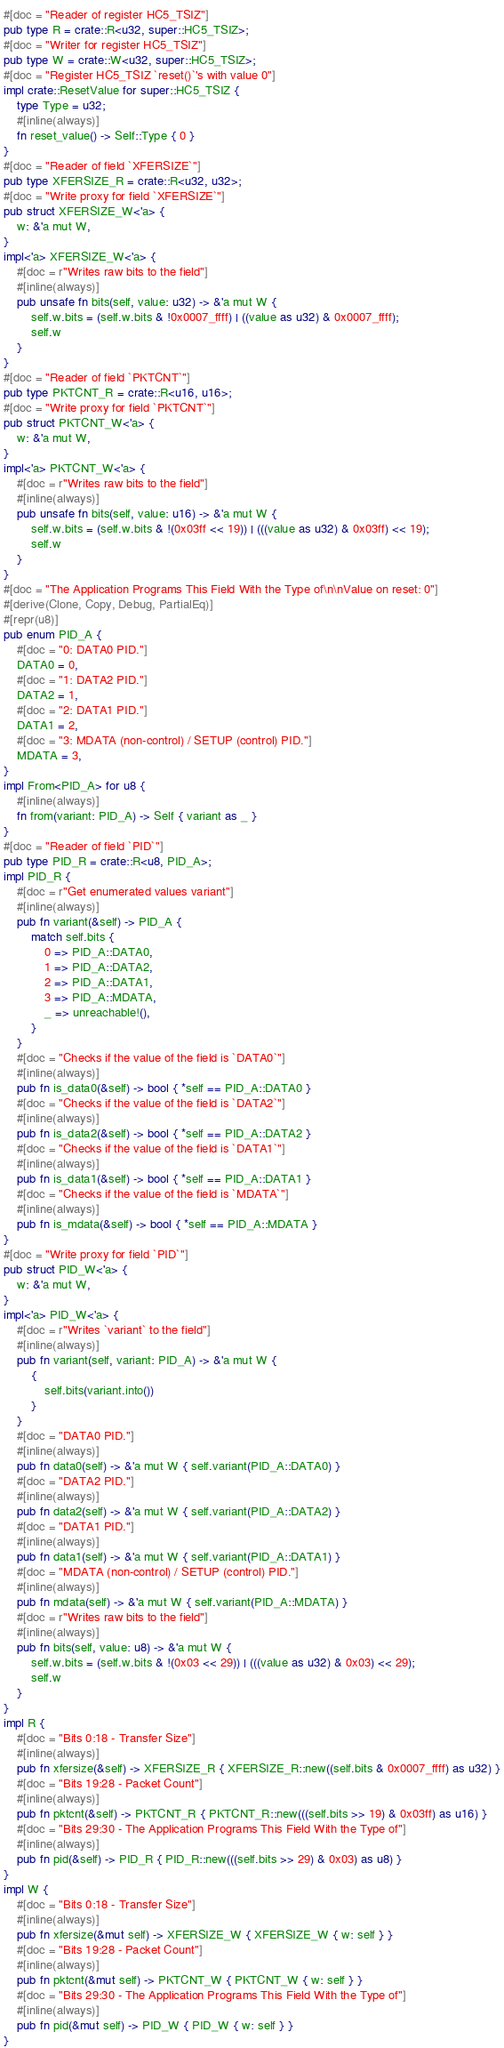<code> <loc_0><loc_0><loc_500><loc_500><_Rust_>#[doc = "Reader of register HC5_TSIZ"]
pub type R = crate::R<u32, super::HC5_TSIZ>;
#[doc = "Writer for register HC5_TSIZ"]
pub type W = crate::W<u32, super::HC5_TSIZ>;
#[doc = "Register HC5_TSIZ `reset()`'s with value 0"]
impl crate::ResetValue for super::HC5_TSIZ {
    type Type = u32;
    #[inline(always)]
    fn reset_value() -> Self::Type { 0 }
}
#[doc = "Reader of field `XFERSIZE`"]
pub type XFERSIZE_R = crate::R<u32, u32>;
#[doc = "Write proxy for field `XFERSIZE`"]
pub struct XFERSIZE_W<'a> {
    w: &'a mut W,
}
impl<'a> XFERSIZE_W<'a> {
    #[doc = r"Writes raw bits to the field"]
    #[inline(always)]
    pub unsafe fn bits(self, value: u32) -> &'a mut W {
        self.w.bits = (self.w.bits & !0x0007_ffff) | ((value as u32) & 0x0007_ffff);
        self.w
    }
}
#[doc = "Reader of field `PKTCNT`"]
pub type PKTCNT_R = crate::R<u16, u16>;
#[doc = "Write proxy for field `PKTCNT`"]
pub struct PKTCNT_W<'a> {
    w: &'a mut W,
}
impl<'a> PKTCNT_W<'a> {
    #[doc = r"Writes raw bits to the field"]
    #[inline(always)]
    pub unsafe fn bits(self, value: u16) -> &'a mut W {
        self.w.bits = (self.w.bits & !(0x03ff << 19)) | (((value as u32) & 0x03ff) << 19);
        self.w
    }
}
#[doc = "The Application Programs This Field With the Type of\n\nValue on reset: 0"]
#[derive(Clone, Copy, Debug, PartialEq)]
#[repr(u8)]
pub enum PID_A {
    #[doc = "0: DATA0 PID."]
    DATA0 = 0,
    #[doc = "1: DATA2 PID."]
    DATA2 = 1,
    #[doc = "2: DATA1 PID."]
    DATA1 = 2,
    #[doc = "3: MDATA (non-control) / SETUP (control) PID."]
    MDATA = 3,
}
impl From<PID_A> for u8 {
    #[inline(always)]
    fn from(variant: PID_A) -> Self { variant as _ }
}
#[doc = "Reader of field `PID`"]
pub type PID_R = crate::R<u8, PID_A>;
impl PID_R {
    #[doc = r"Get enumerated values variant"]
    #[inline(always)]
    pub fn variant(&self) -> PID_A {
        match self.bits {
            0 => PID_A::DATA0,
            1 => PID_A::DATA2,
            2 => PID_A::DATA1,
            3 => PID_A::MDATA,
            _ => unreachable!(),
        }
    }
    #[doc = "Checks if the value of the field is `DATA0`"]
    #[inline(always)]
    pub fn is_data0(&self) -> bool { *self == PID_A::DATA0 }
    #[doc = "Checks if the value of the field is `DATA2`"]
    #[inline(always)]
    pub fn is_data2(&self) -> bool { *self == PID_A::DATA2 }
    #[doc = "Checks if the value of the field is `DATA1`"]
    #[inline(always)]
    pub fn is_data1(&self) -> bool { *self == PID_A::DATA1 }
    #[doc = "Checks if the value of the field is `MDATA`"]
    #[inline(always)]
    pub fn is_mdata(&self) -> bool { *self == PID_A::MDATA }
}
#[doc = "Write proxy for field `PID`"]
pub struct PID_W<'a> {
    w: &'a mut W,
}
impl<'a> PID_W<'a> {
    #[doc = r"Writes `variant` to the field"]
    #[inline(always)]
    pub fn variant(self, variant: PID_A) -> &'a mut W {
        {
            self.bits(variant.into())
        }
    }
    #[doc = "DATA0 PID."]
    #[inline(always)]
    pub fn data0(self) -> &'a mut W { self.variant(PID_A::DATA0) }
    #[doc = "DATA2 PID."]
    #[inline(always)]
    pub fn data2(self) -> &'a mut W { self.variant(PID_A::DATA2) }
    #[doc = "DATA1 PID."]
    #[inline(always)]
    pub fn data1(self) -> &'a mut W { self.variant(PID_A::DATA1) }
    #[doc = "MDATA (non-control) / SETUP (control) PID."]
    #[inline(always)]
    pub fn mdata(self) -> &'a mut W { self.variant(PID_A::MDATA) }
    #[doc = r"Writes raw bits to the field"]
    #[inline(always)]
    pub fn bits(self, value: u8) -> &'a mut W {
        self.w.bits = (self.w.bits & !(0x03 << 29)) | (((value as u32) & 0x03) << 29);
        self.w
    }
}
impl R {
    #[doc = "Bits 0:18 - Transfer Size"]
    #[inline(always)]
    pub fn xfersize(&self) -> XFERSIZE_R { XFERSIZE_R::new((self.bits & 0x0007_ffff) as u32) }
    #[doc = "Bits 19:28 - Packet Count"]
    #[inline(always)]
    pub fn pktcnt(&self) -> PKTCNT_R { PKTCNT_R::new(((self.bits >> 19) & 0x03ff) as u16) }
    #[doc = "Bits 29:30 - The Application Programs This Field With the Type of"]
    #[inline(always)]
    pub fn pid(&self) -> PID_R { PID_R::new(((self.bits >> 29) & 0x03) as u8) }
}
impl W {
    #[doc = "Bits 0:18 - Transfer Size"]
    #[inline(always)]
    pub fn xfersize(&mut self) -> XFERSIZE_W { XFERSIZE_W { w: self } }
    #[doc = "Bits 19:28 - Packet Count"]
    #[inline(always)]
    pub fn pktcnt(&mut self) -> PKTCNT_W { PKTCNT_W { w: self } }
    #[doc = "Bits 29:30 - The Application Programs This Field With the Type of"]
    #[inline(always)]
    pub fn pid(&mut self) -> PID_W { PID_W { w: self } }
}
</code> 